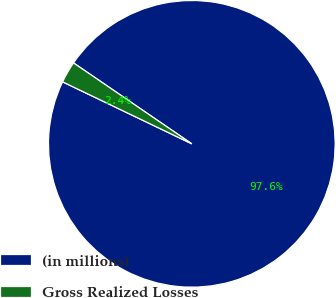<chart> <loc_0><loc_0><loc_500><loc_500><pie_chart><fcel>(in millions)<fcel>Gross Realized Losses<nl><fcel>97.57%<fcel>2.43%<nl></chart> 